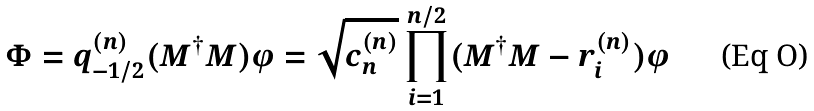<formula> <loc_0><loc_0><loc_500><loc_500>\Phi = q _ { - 1 / 2 } ^ { ( n ) } ( M ^ { \dagger } M ) \varphi = \sqrt { c _ { n } ^ { ( n ) } } \prod _ { i = 1 } ^ { n / 2 } ( M ^ { \dagger } M - r ^ { ( n ) } _ { i } ) \varphi</formula> 